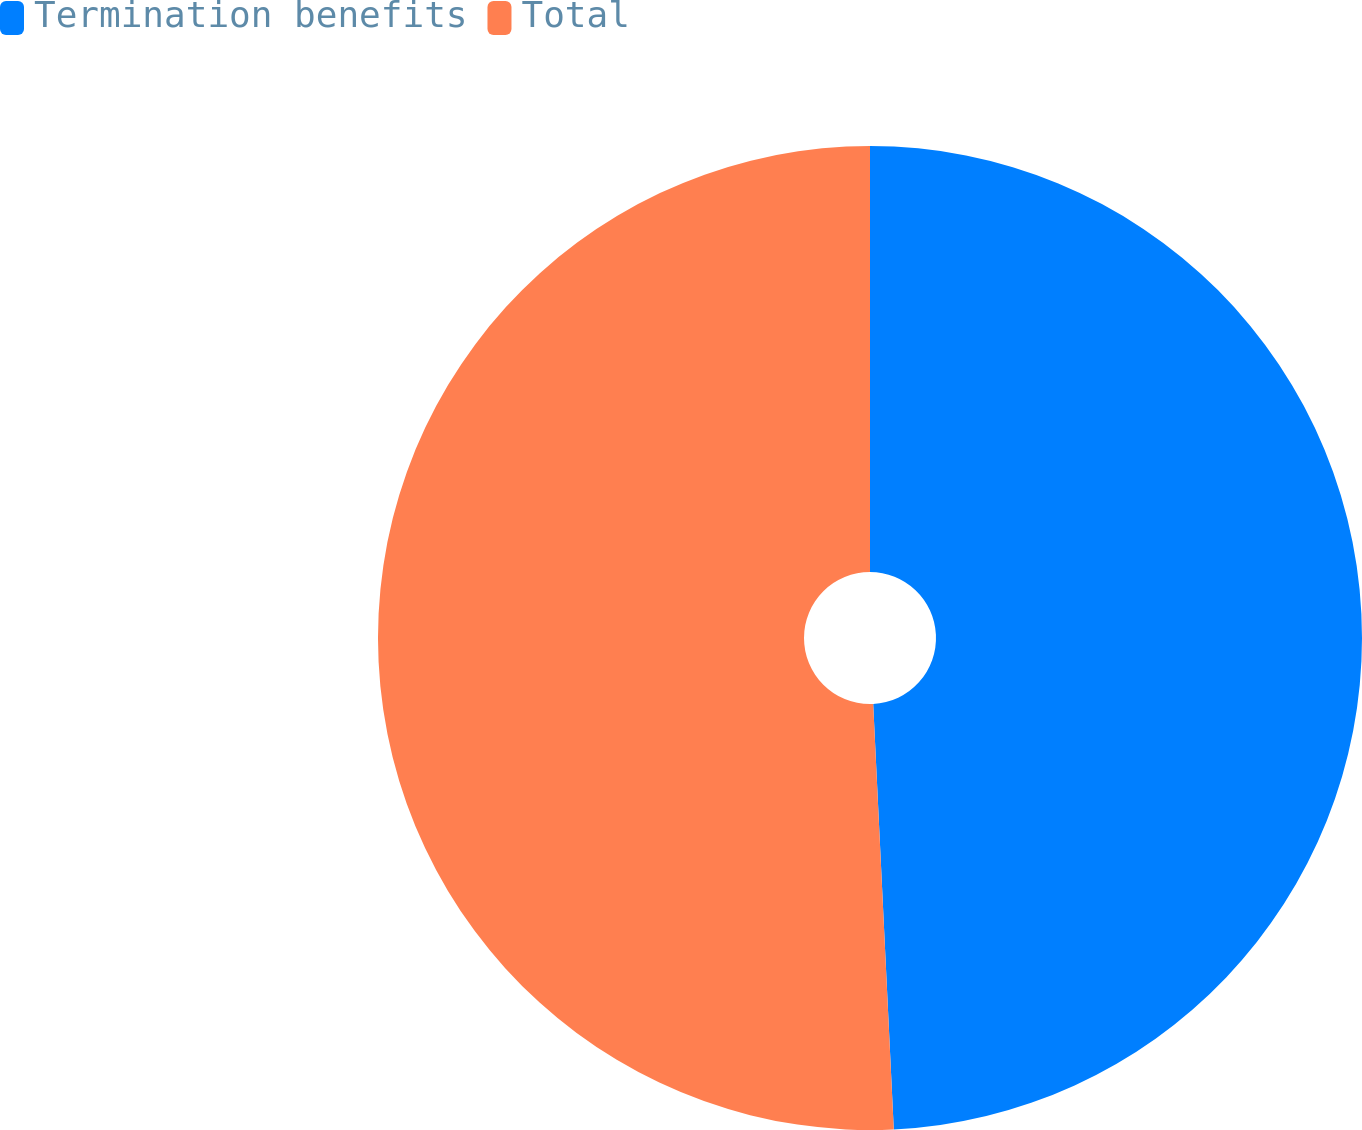Convert chart to OTSL. <chart><loc_0><loc_0><loc_500><loc_500><pie_chart><fcel>Termination benefits<fcel>Total<nl><fcel>49.23%<fcel>50.77%<nl></chart> 